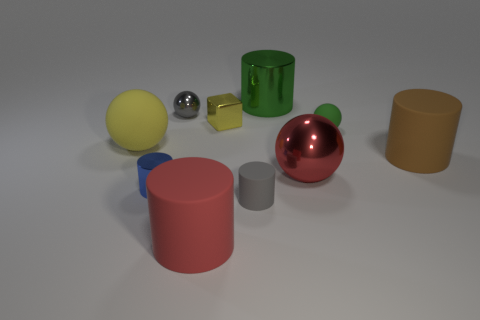Subtract all big rubber cylinders. How many cylinders are left? 3 Subtract all yellow balls. How many balls are left? 3 Subtract 1 cylinders. How many cylinders are left? 4 Add 5 tiny gray shiny spheres. How many tiny gray shiny spheres exist? 6 Subtract 1 yellow cubes. How many objects are left? 9 Subtract all balls. How many objects are left? 6 Subtract all cyan blocks. Subtract all green cylinders. How many blocks are left? 1 Subtract all gray balls. How many red cylinders are left? 1 Subtract all large yellow shiny spheres. Subtract all small blue things. How many objects are left? 9 Add 9 large metallic cylinders. How many large metallic cylinders are left? 10 